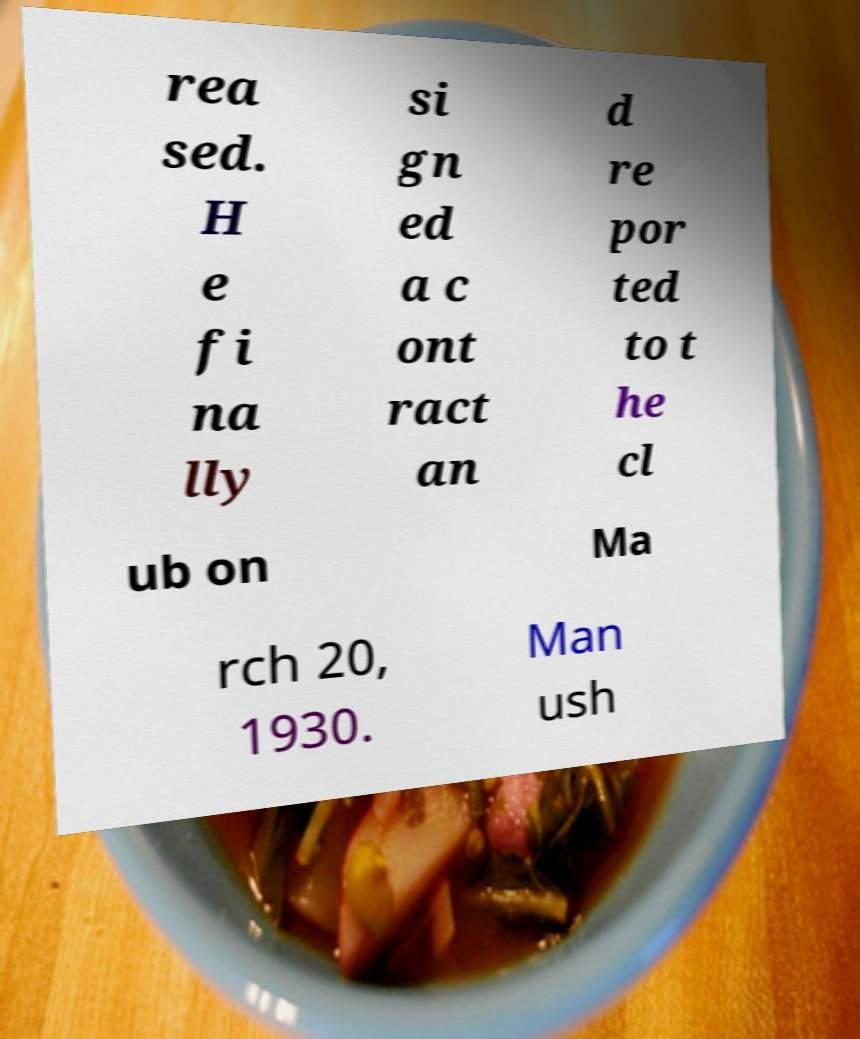I need the written content from this picture converted into text. Can you do that? rea sed. H e fi na lly si gn ed a c ont ract an d re por ted to t he cl ub on Ma rch 20, 1930. Man ush 